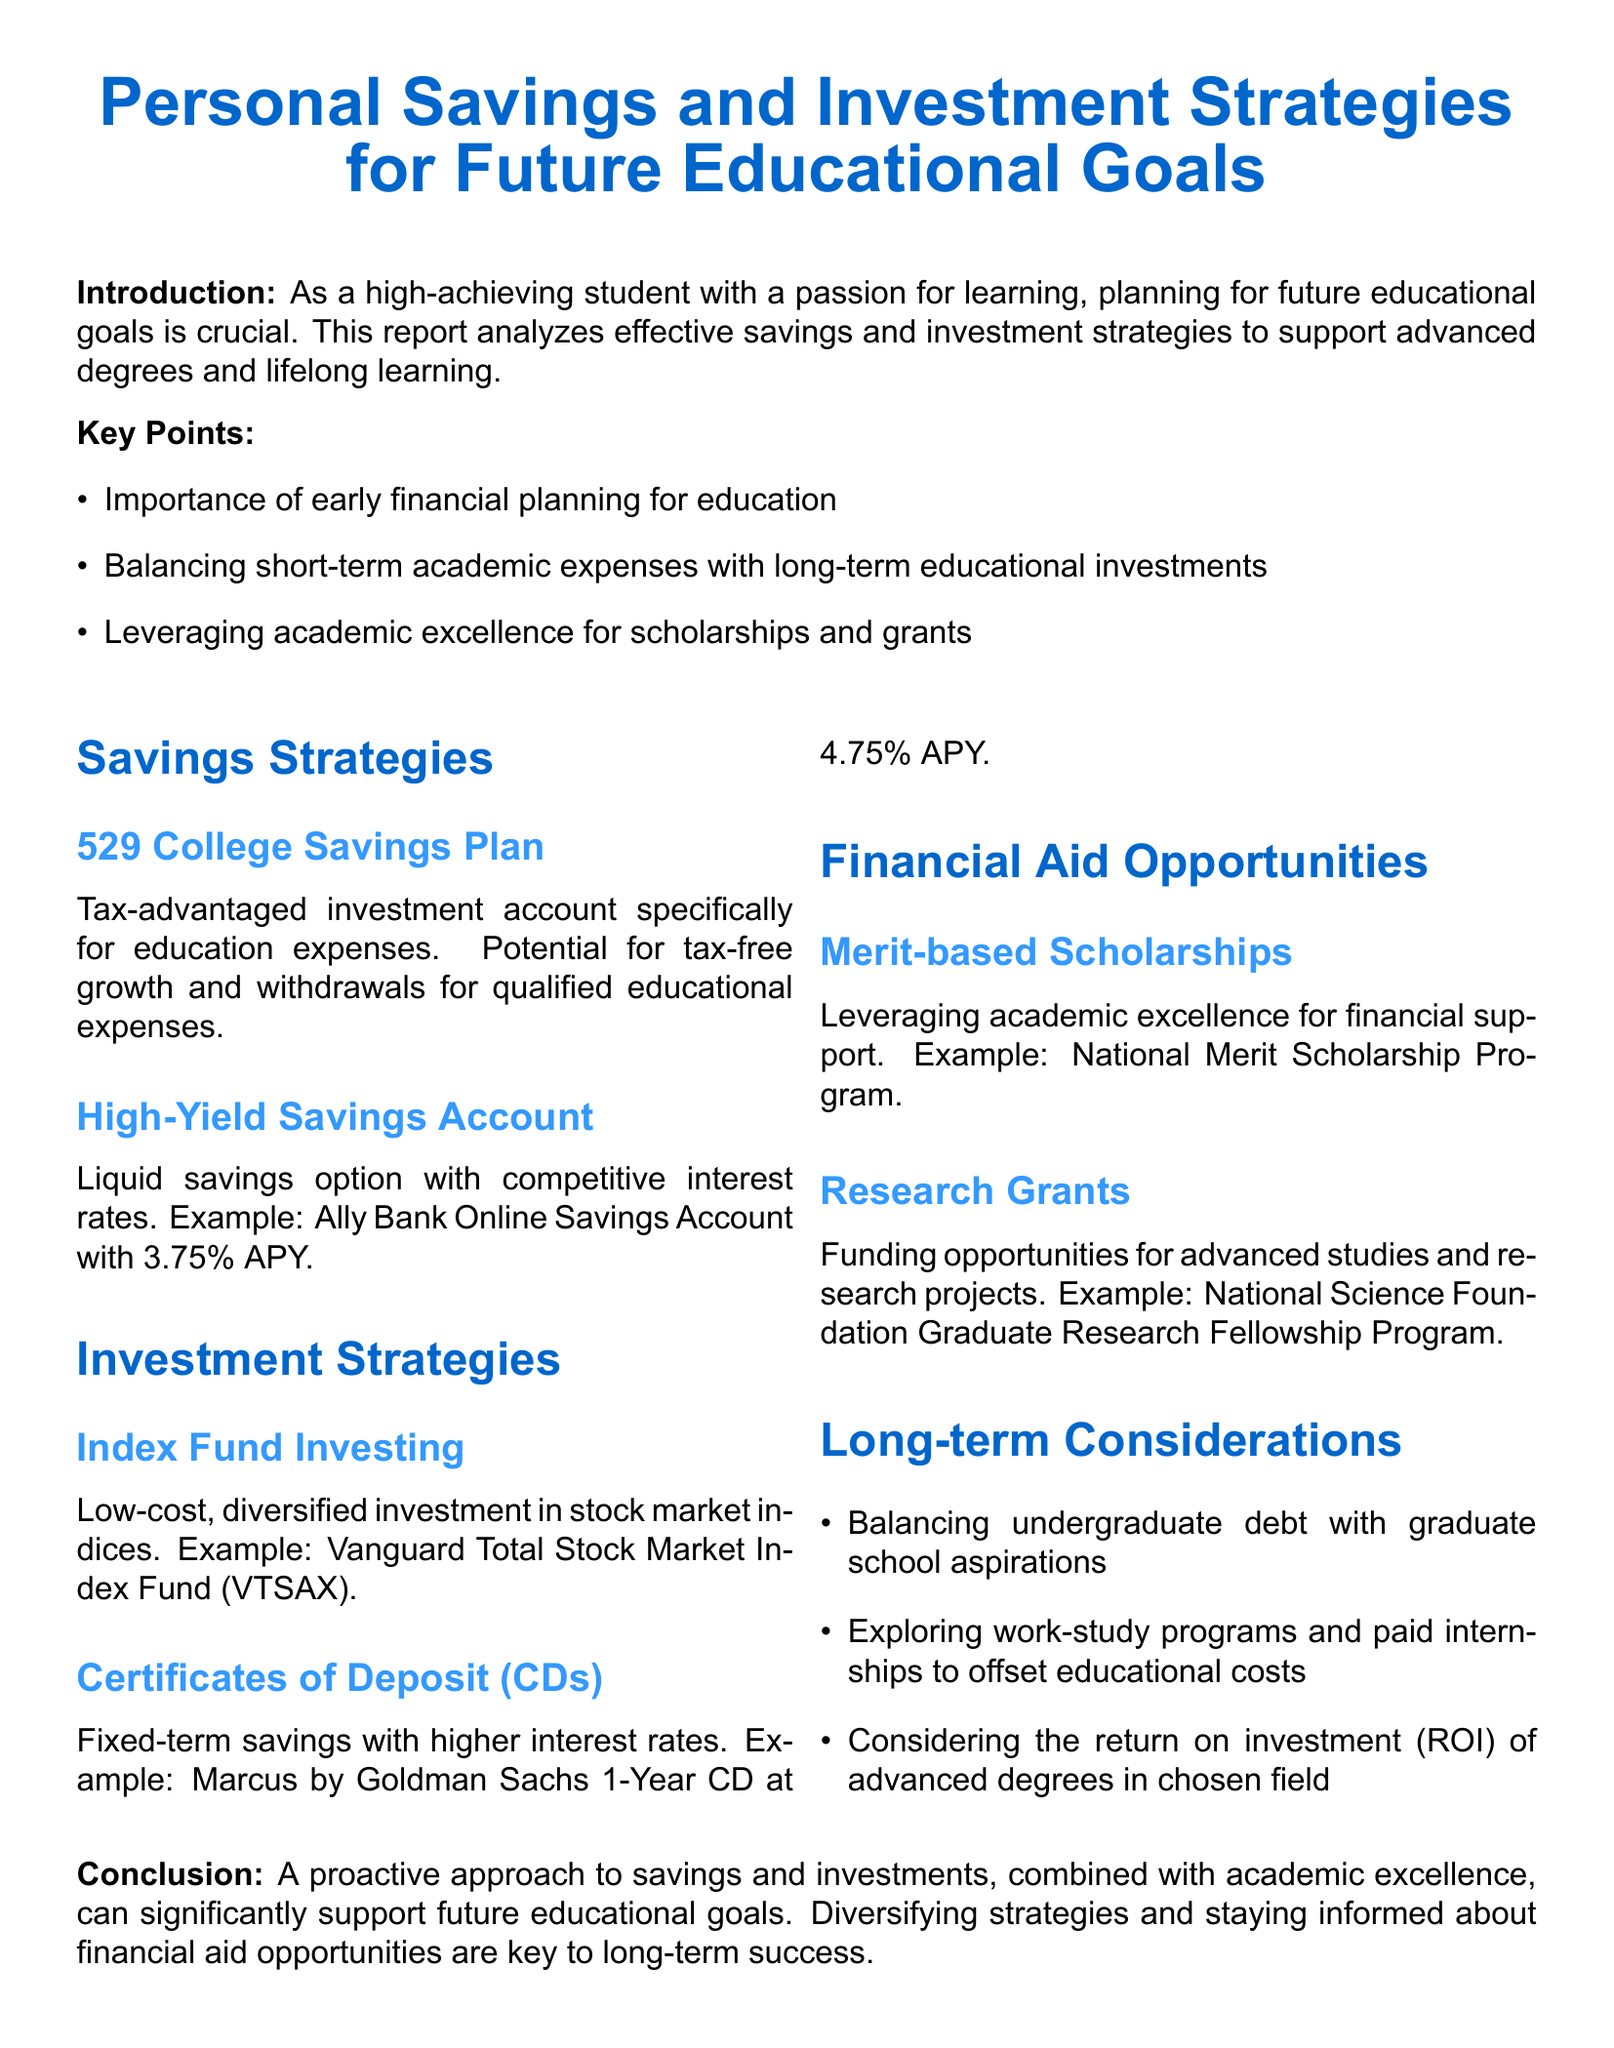What is the title of the report? The title of the report is presented at the beginning, which is "Personal Savings and Investment Strategies for Future Educational Goals."
Answer: Personal Savings and Investment Strategies for Future Educational Goals What type of account is a 529 College Savings Plan? The document describes a 529 College Savings Plan as a "tax-advantaged investment account specifically for education expenses."
Answer: tax-advantaged investment account What is the APY of the High-Yield Savings Account mentioned? The example given for the High-Yield Savings Account contains the interest rate, which is 3.75% APY.
Answer: 3.75% APY What is a key point mentioned in the report? The document lists several key points, one of which is "Importance of early financial planning for education."
Answer: Importance of early financial planning for education Which investment strategy involves low-cost, diversified investment? The report mentions "Index Fund Investing" as the strategy that involves low-cost, diversified investment in stock market indices.
Answer: Index Fund Investing What kind of scholarships can be leveraged according to the report? The report specifies "Merit-based Scholarships" as a type of scholarship that can be leveraged for financial support.
Answer: Merit-based Scholarships What should be balanced with graduate school aspirations? One of the long-term considerations mentioned is "Balancing undergraduate debt with graduate school aspirations."
Answer: undergraduate debt Which financial aid opportunity is specifically for advanced studies? The report identifies "Research Grants" as the funding opportunities for advanced studies and research projects.
Answer: Research Grants What is the key to long-term success according to the conclusion? The conclusion states that "Diversifying strategies and staying informed about financial aid opportunities are key to long-term success."
Answer: Diversifying strategies and staying informed about financial aid opportunities 